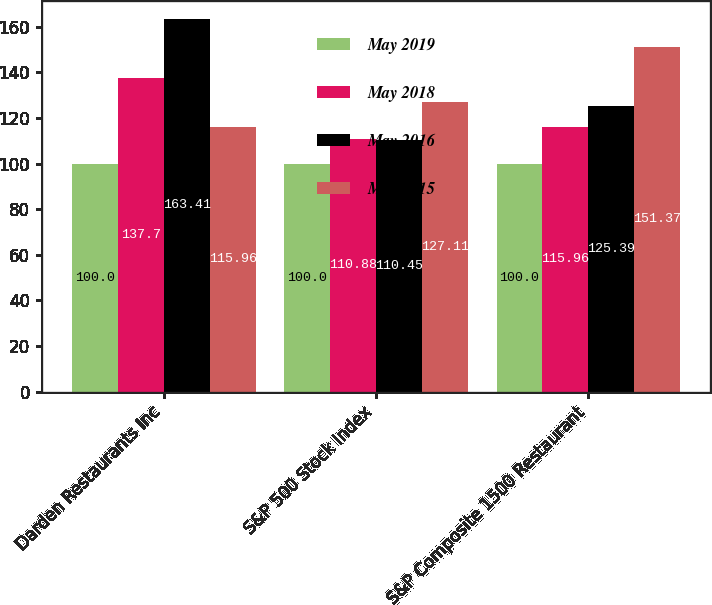Convert chart to OTSL. <chart><loc_0><loc_0><loc_500><loc_500><stacked_bar_chart><ecel><fcel>Darden Restaurants Inc<fcel>S&P 500 Stock Index<fcel>S&P Composite 1500 Restaurant<nl><fcel>May 2019<fcel>100<fcel>100<fcel>100<nl><fcel>May 2018<fcel>137.7<fcel>110.88<fcel>115.96<nl><fcel>May 2016<fcel>163.41<fcel>110.45<fcel>125.39<nl><fcel>May 2015<fcel>115.96<fcel>127.11<fcel>151.37<nl></chart> 